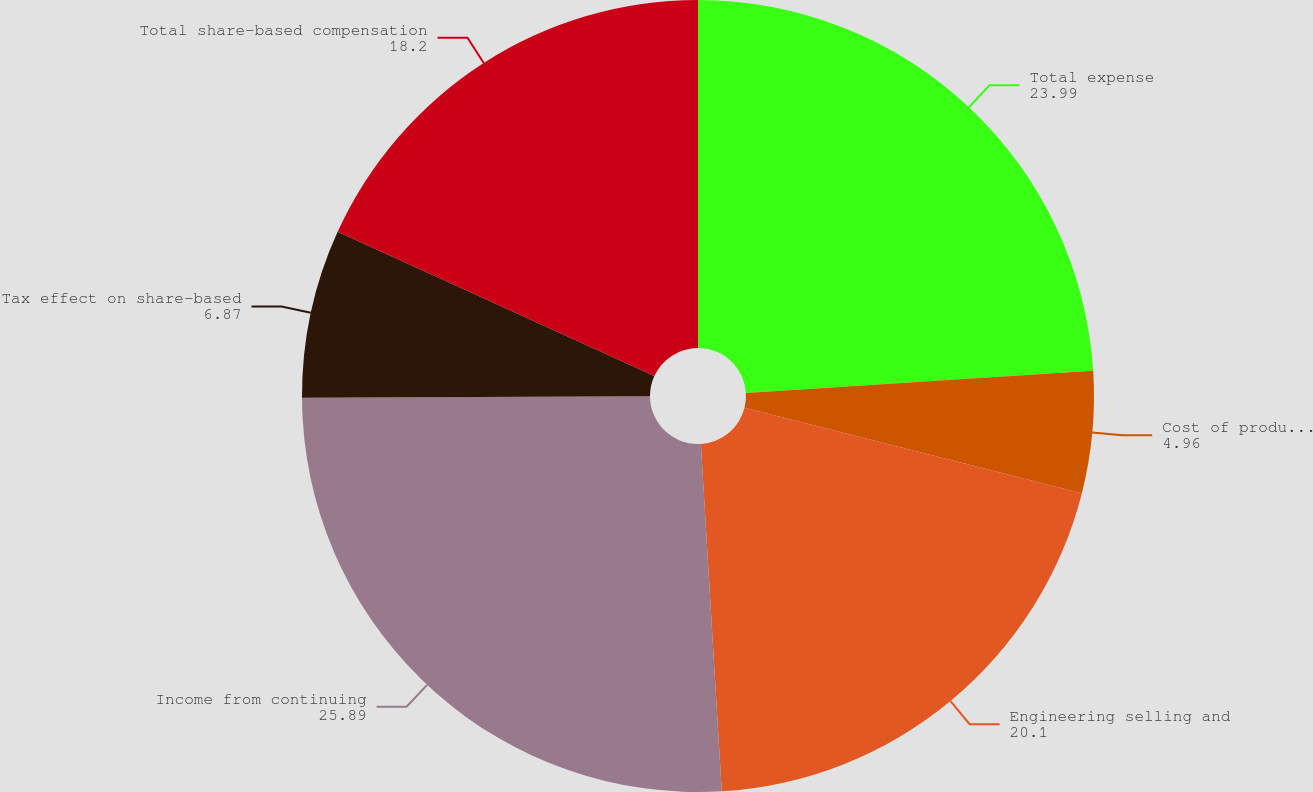Convert chart to OTSL. <chart><loc_0><loc_0><loc_500><loc_500><pie_chart><fcel>Total expense<fcel>Cost of product sales and<fcel>Engineering selling and<fcel>Income from continuing<fcel>Tax effect on share-based<fcel>Total share-based compensation<nl><fcel>23.99%<fcel>4.96%<fcel>20.1%<fcel>25.89%<fcel>6.87%<fcel>18.2%<nl></chart> 